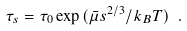<formula> <loc_0><loc_0><loc_500><loc_500>\tau _ { s } = \tau _ { 0 } \exp { ( \bar { \mu } s ^ { 2 / 3 } / k _ { B } T ) } \ .</formula> 